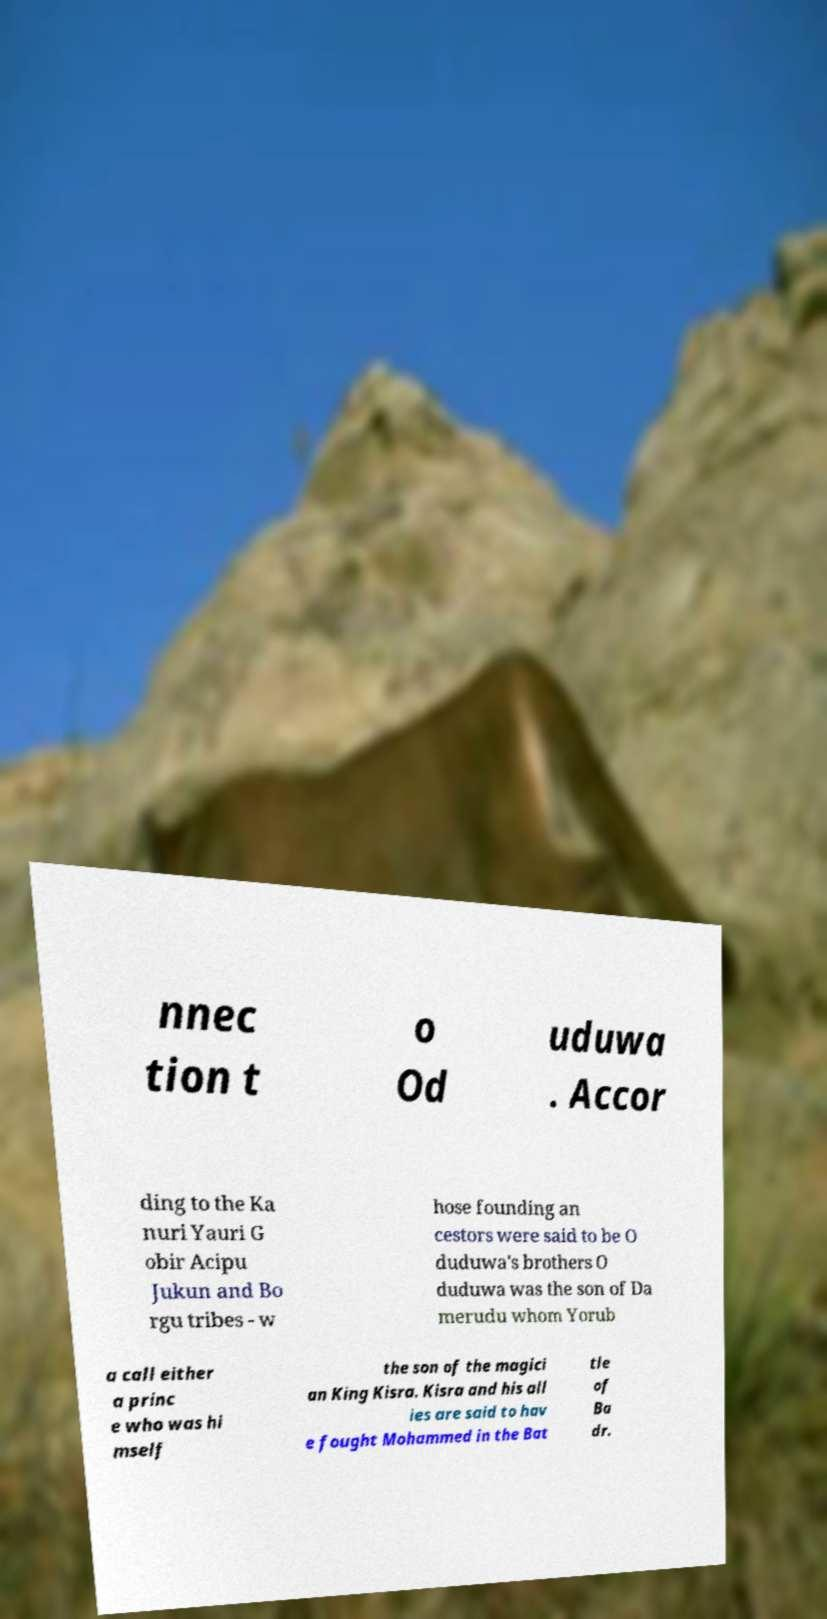Could you assist in decoding the text presented in this image and type it out clearly? nnec tion t o Od uduwa . Accor ding to the Ka nuri Yauri G obir Acipu Jukun and Bo rgu tribes - w hose founding an cestors were said to be O duduwa's brothers O duduwa was the son of Da merudu whom Yorub a call either a princ e who was hi mself the son of the magici an King Kisra. Kisra and his all ies are said to hav e fought Mohammed in the Bat tle of Ba dr. 